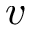<formula> <loc_0><loc_0><loc_500><loc_500>v</formula> 